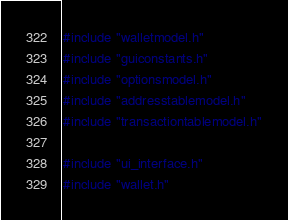<code> <loc_0><loc_0><loc_500><loc_500><_C++_>#include "walletmodel.h"
#include "guiconstants.h"
#include "optionsmodel.h"
#include "addresstablemodel.h"
#include "transactiontablemodel.h"

#include "ui_interface.h"
#include "wallet.h"</code> 